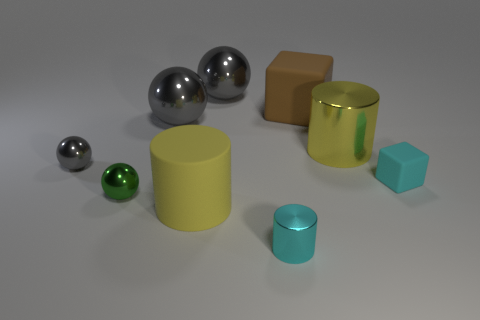Can you describe the lighting in the image? The lighting in the image appears to be soft and diffused, with subtle shadows cast directly beneath each object, which suggests an overhead light source, possibly positioned to minimize harsh shadows. Is there anything about the arrangement of objects that seems deliberate? The objects are arranged in a scattered, yet balanced composition, with spacing that allows each shape to be distinct. This could indicate a deliberate setup to showcase the diversity of shapes and materials. 